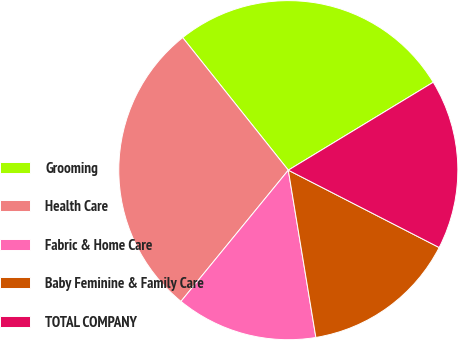Convert chart to OTSL. <chart><loc_0><loc_0><loc_500><loc_500><pie_chart><fcel>Grooming<fcel>Health Care<fcel>Fabric & Home Care<fcel>Baby Feminine & Family Care<fcel>TOTAL COMPANY<nl><fcel>27.03%<fcel>28.38%<fcel>13.51%<fcel>14.86%<fcel>16.22%<nl></chart> 